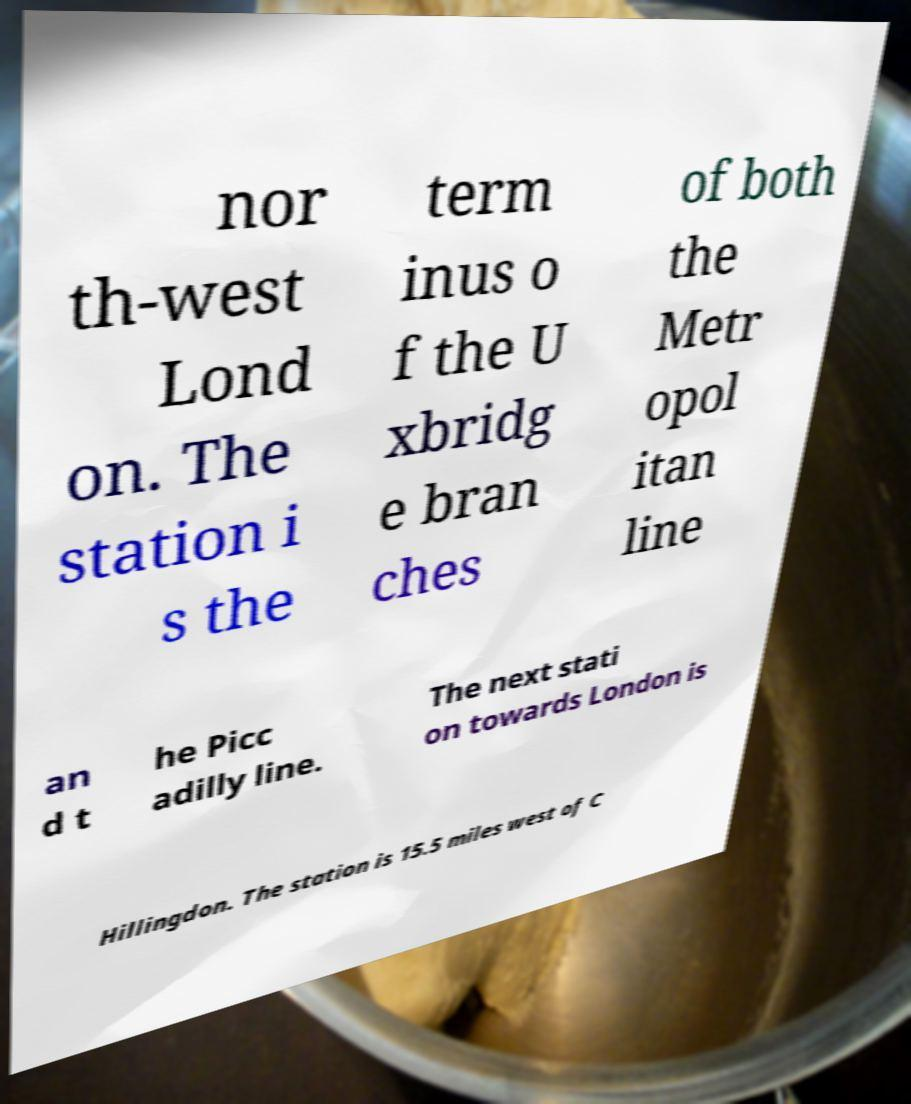Could you extract and type out the text from this image? nor th-west Lond on. The station i s the term inus o f the U xbridg e bran ches of both the Metr opol itan line an d t he Picc adilly line. The next stati on towards London is Hillingdon. The station is 15.5 miles west of C 